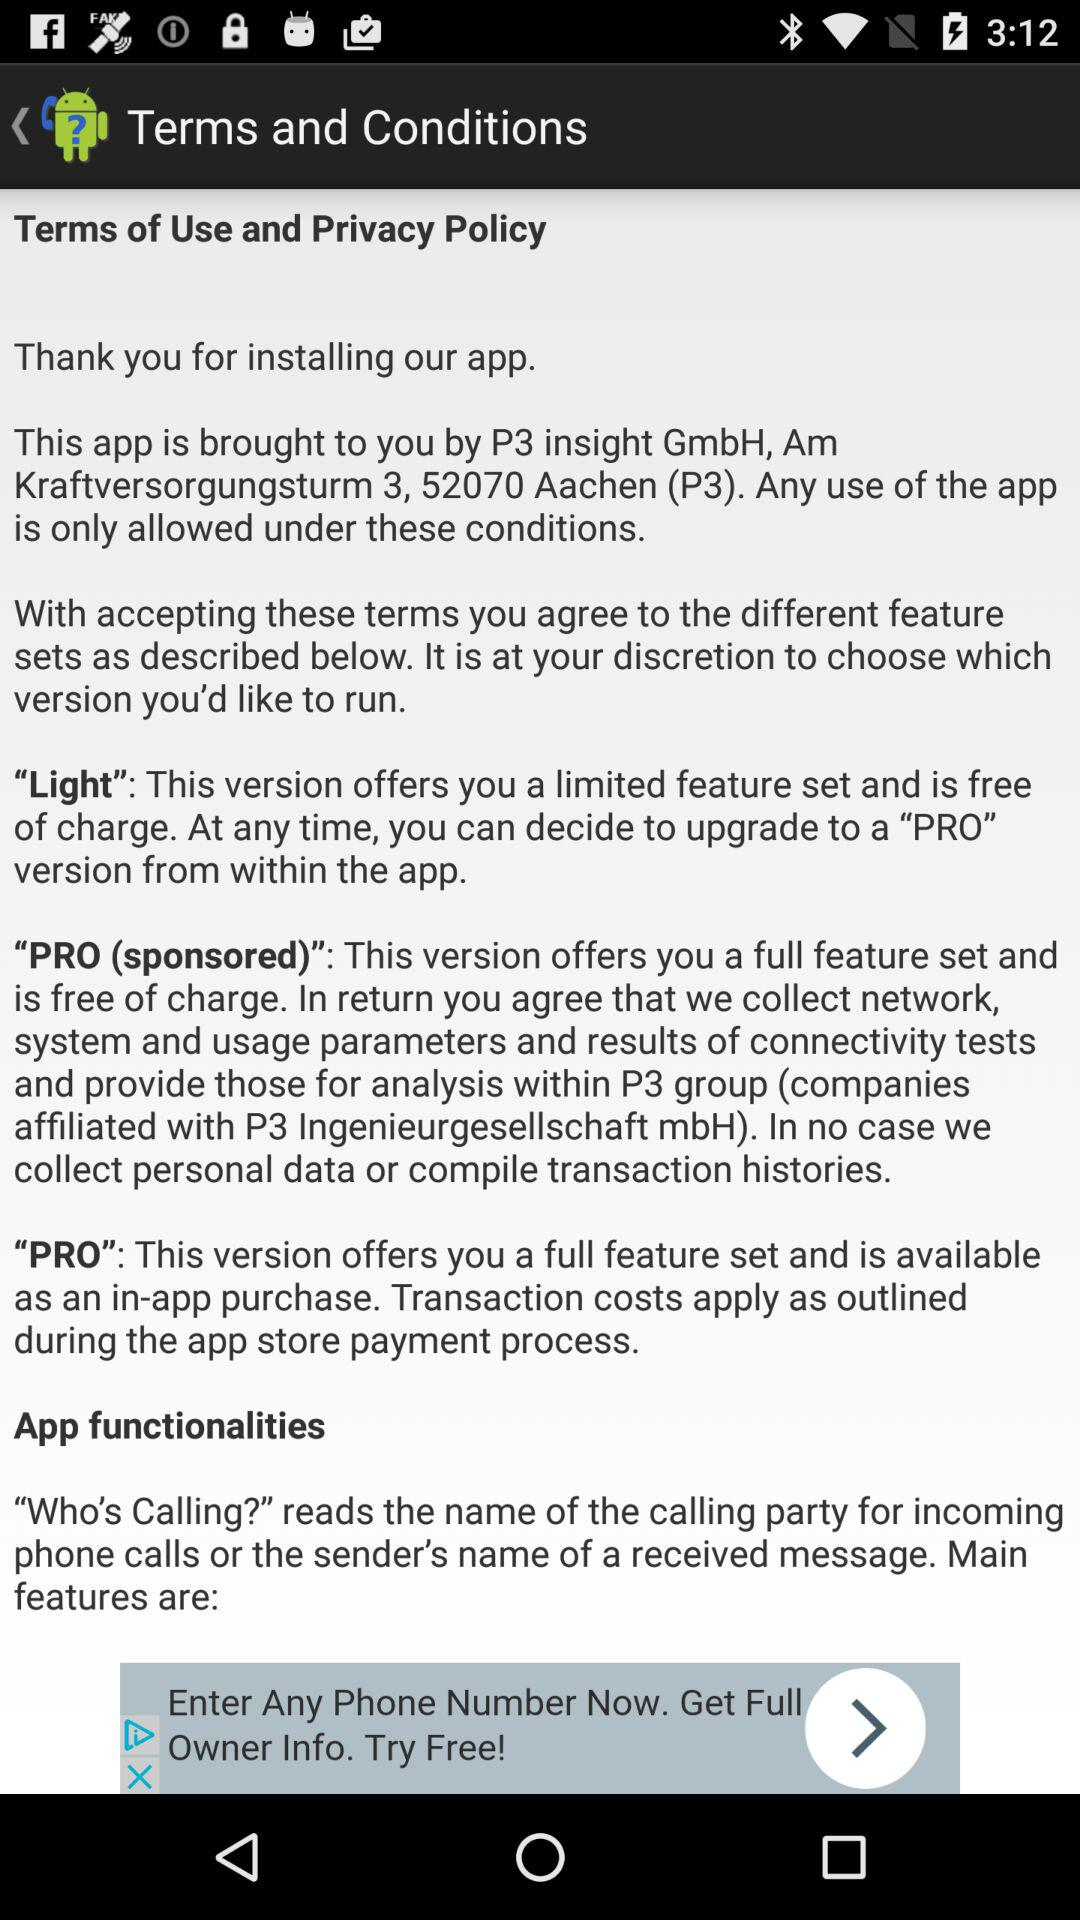How many of the versions are free?
Answer the question using a single word or phrase. 2 